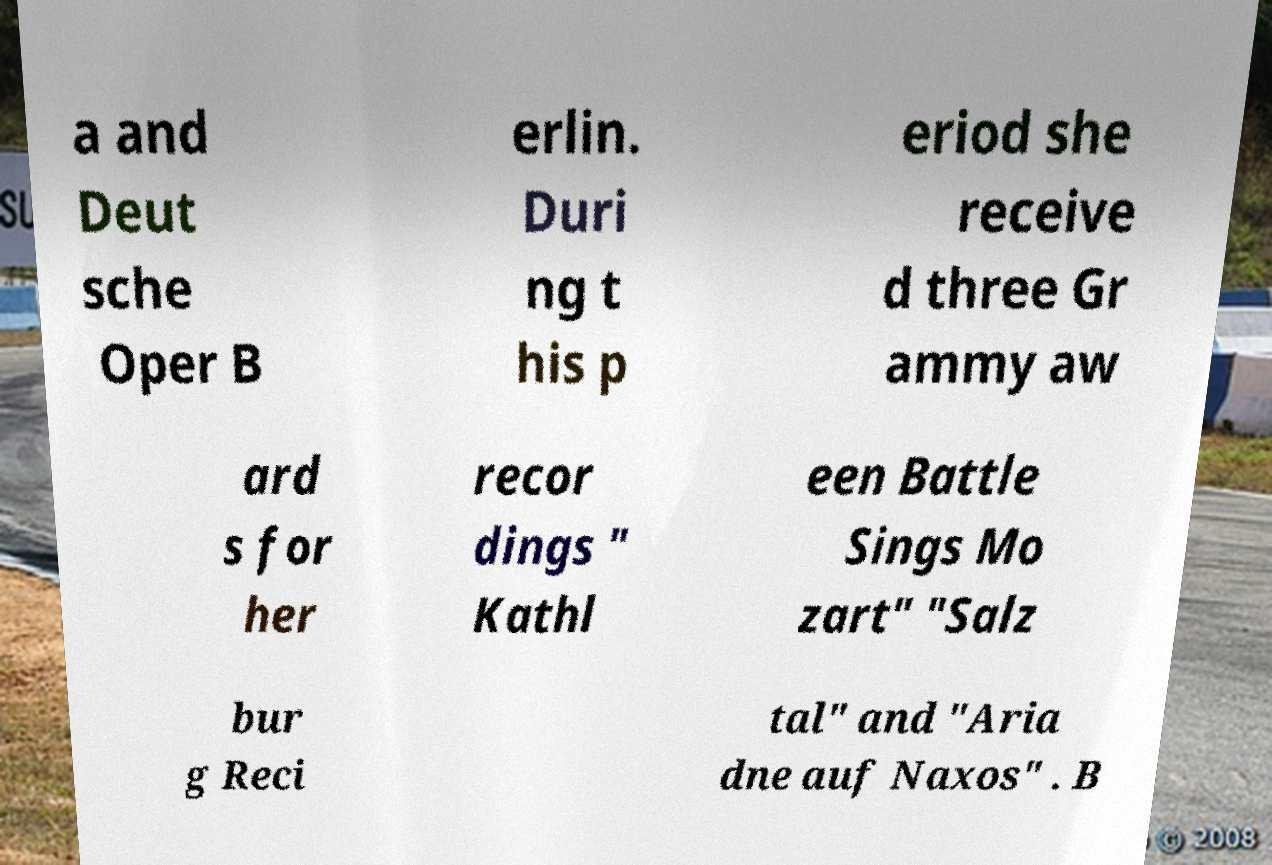Can you accurately transcribe the text from the provided image for me? a and Deut sche Oper B erlin. Duri ng t his p eriod she receive d three Gr ammy aw ard s for her recor dings " Kathl een Battle Sings Mo zart" "Salz bur g Reci tal" and "Aria dne auf Naxos" . B 